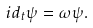<formula> <loc_0><loc_0><loc_500><loc_500>i d _ { t } \psi = \omega \psi .</formula> 